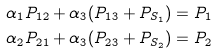Convert formula to latex. <formula><loc_0><loc_0><loc_500><loc_500>\alpha _ { 1 } P _ { 1 2 } + \alpha _ { 3 } ( P _ { 1 3 } + P _ { S _ { 1 } } ) & = P _ { 1 } \\ \alpha _ { 2 } P _ { 2 1 } + \alpha _ { 3 } ( P _ { 2 3 } + P _ { S _ { 2 } } ) & = P _ { 2 }</formula> 